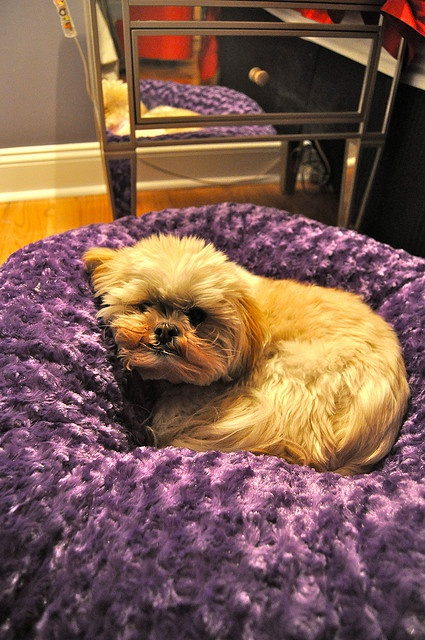Describe the objects in this image and their specific colors. I can see a dog in gray, orange, khaki, gold, and brown tones in this image. 